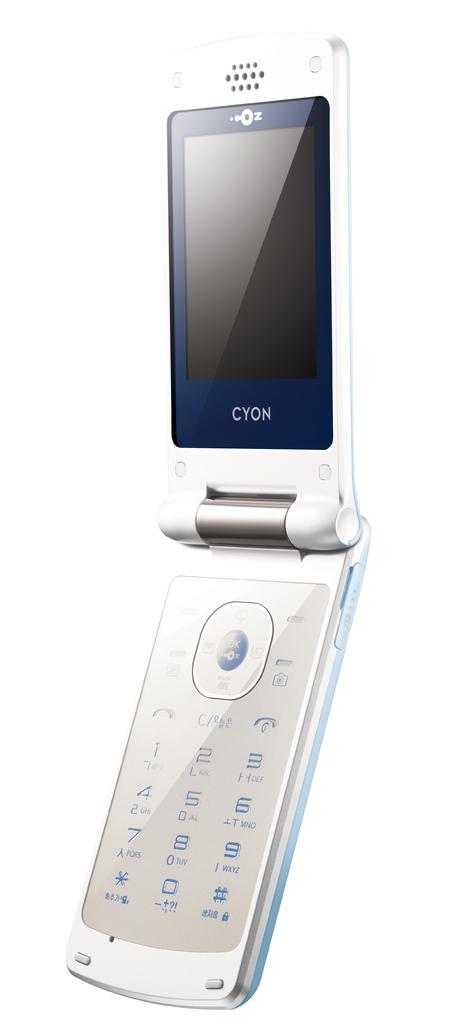What phone brand is this?
Provide a succinct answer. Cyon. What number is located at the very bottom?
Ensure brevity in your answer.  0. 